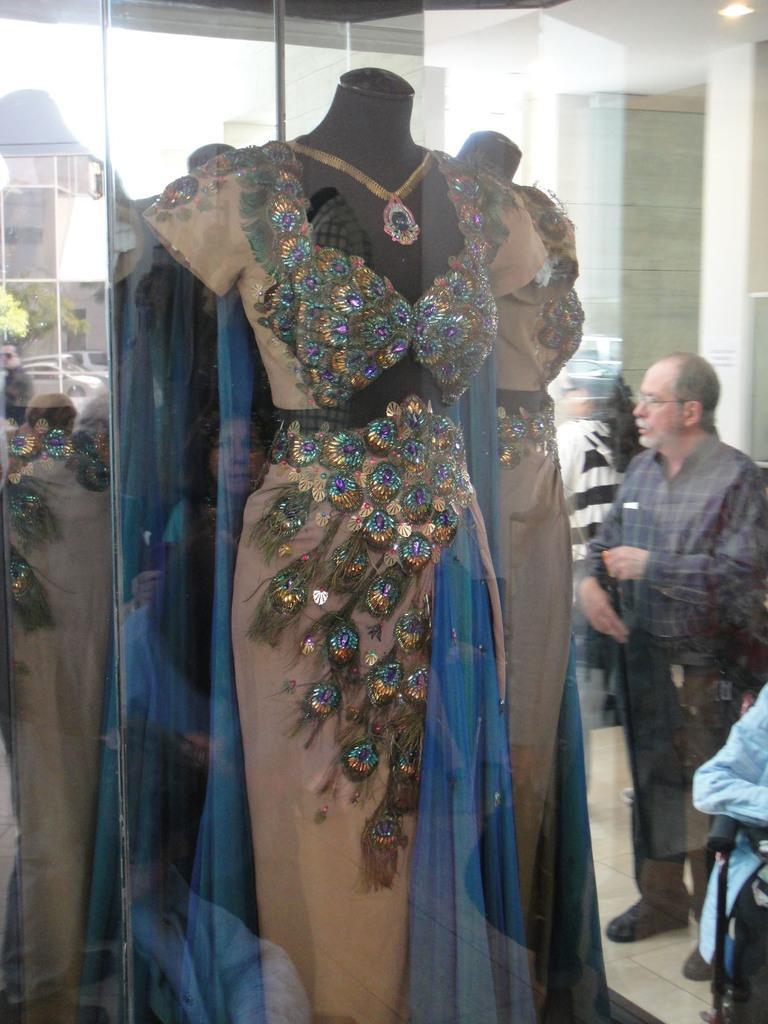Please provide a concise description of this image. In this image in the front there is a statue and on the statue there is a dress. In the background there are persons standing and there are cars, there are buildings, trees. 